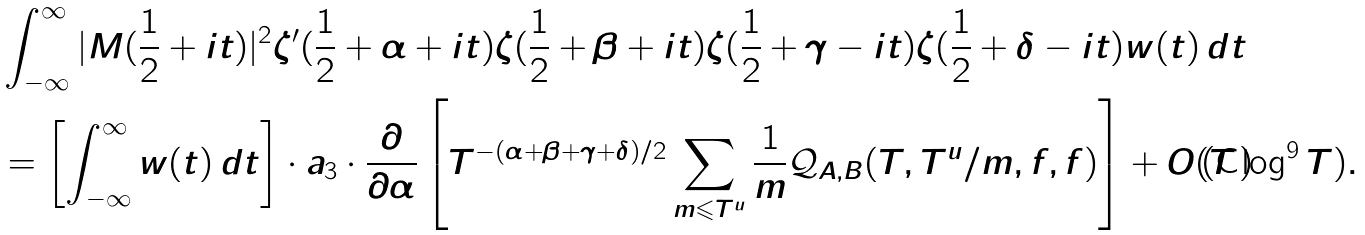Convert formula to latex. <formula><loc_0><loc_0><loc_500><loc_500>& \int _ { - \infty } ^ { \infty } | M ( \frac { 1 } { 2 } + i t ) | ^ { 2 } \zeta ^ { \prime } ( \frac { 1 } { 2 } + \alpha + i t ) \zeta ( \frac { 1 } { 2 } + \beta + i t ) \zeta ( \frac { 1 } { 2 } + \gamma - i t ) \zeta ( \frac { 1 } { 2 } + \delta - i t ) w ( t ) \, d t \\ & = \left [ \int _ { - \infty } ^ { \infty } w ( t ) \, d t \right ] \cdot a _ { 3 } \cdot \frac { \partial } { \partial \alpha } \left [ T ^ { - ( \alpha + \beta + \gamma + \delta ) / 2 } \sum _ { m \leqslant T ^ { u } } \frac { 1 } { m } \mathcal { Q } _ { A , B } ( T , T ^ { u } / m , f , f ) \right ] + O ( T \log ^ { 9 } { T } ) .</formula> 